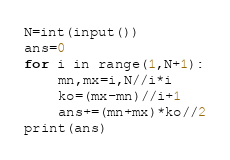<code> <loc_0><loc_0><loc_500><loc_500><_Python_>N=int(input())
ans=0
for i in range(1,N+1):
    mn,mx=i,N//i*i
    ko=(mx-mn)//i+1
    ans+=(mn+mx)*ko//2
print(ans)</code> 